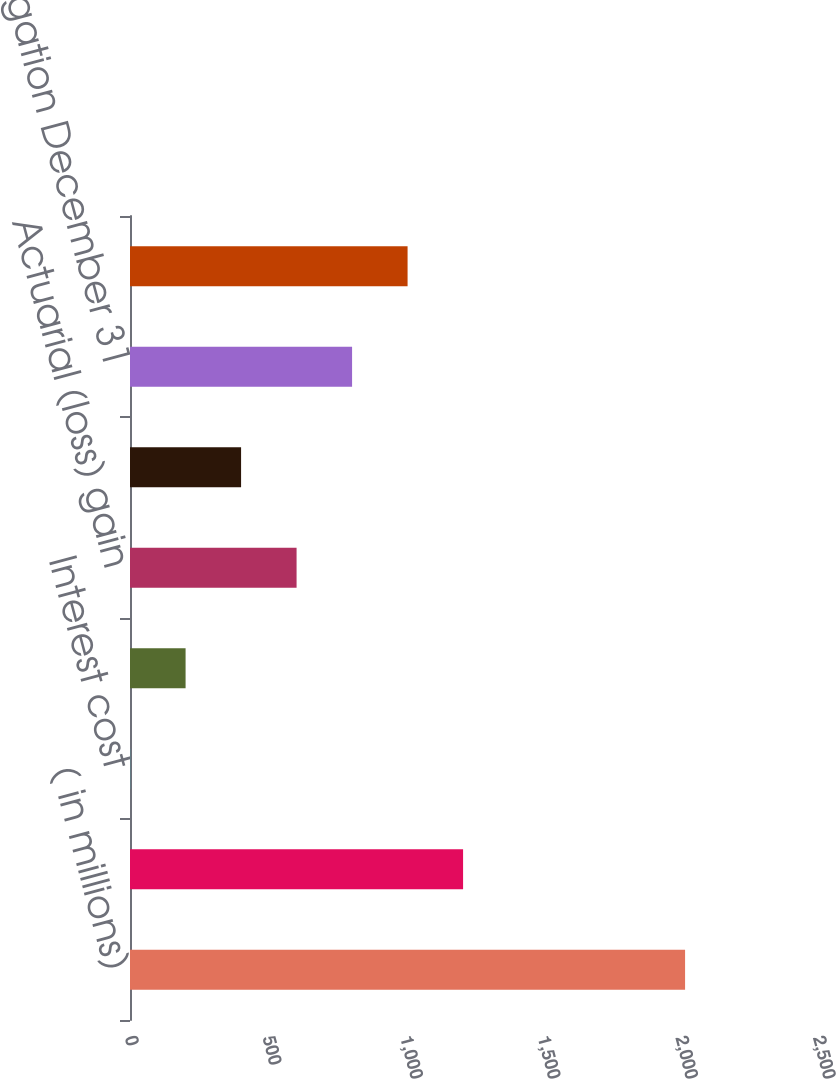<chart> <loc_0><loc_0><loc_500><loc_500><bar_chart><fcel>( in millions)<fcel>Benefit obligation January 1<fcel>Interest cost<fcel>Participants' contributions<fcel>Actuarial (loss) gain<fcel>Benefits/expenses paid<fcel>Benefit obligation December 31<fcel>Funded status at end of year<nl><fcel>2017<fcel>1210.32<fcel>0.3<fcel>201.97<fcel>605.31<fcel>403.64<fcel>806.98<fcel>1008.65<nl></chart> 